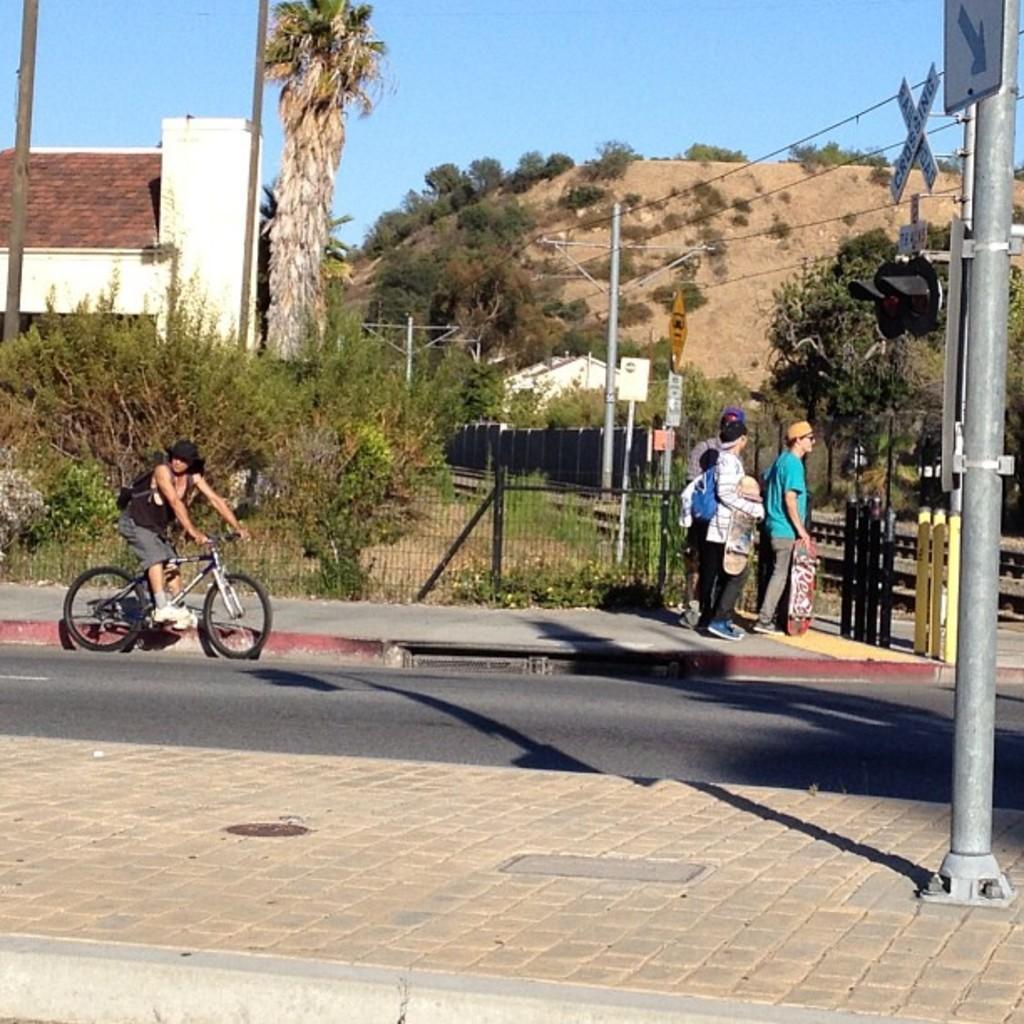Please provide a concise description of this image. A person is sitting on a bicycle. Here we can see people holding skateboards. Background there are plants, fence, tree and house. Sign Boards and signal light is on pole. 